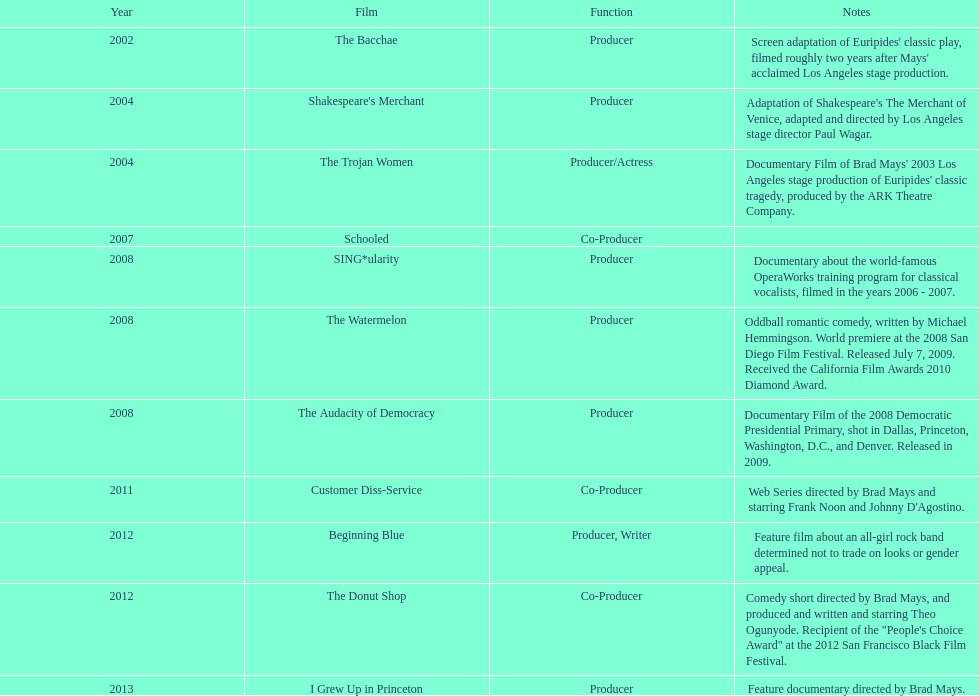How much time passed between the release of the film "schooled out" and the beginning of "blue"? 5 years. 